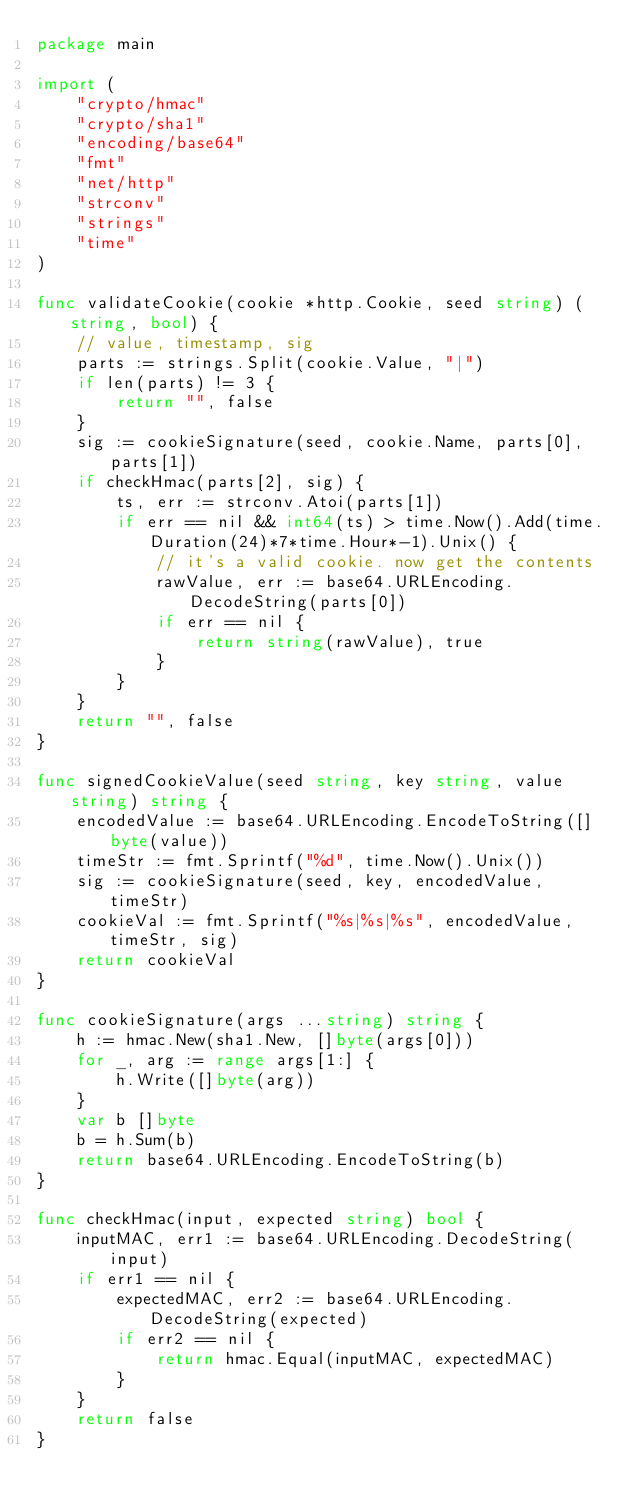<code> <loc_0><loc_0><loc_500><loc_500><_Go_>package main

import (
	"crypto/hmac"
	"crypto/sha1"
	"encoding/base64"
	"fmt"
	"net/http"
	"strconv"
	"strings"
	"time"
)

func validateCookie(cookie *http.Cookie, seed string) (string, bool) {
	// value, timestamp, sig
	parts := strings.Split(cookie.Value, "|")
	if len(parts) != 3 {
		return "", false
	}
	sig := cookieSignature(seed, cookie.Name, parts[0], parts[1])
	if checkHmac(parts[2], sig) {
		ts, err := strconv.Atoi(parts[1])
		if err == nil && int64(ts) > time.Now().Add(time.Duration(24)*7*time.Hour*-1).Unix() {
			// it's a valid cookie. now get the contents
			rawValue, err := base64.URLEncoding.DecodeString(parts[0])
			if err == nil {
				return string(rawValue), true
			}
		}
	}
	return "", false
}

func signedCookieValue(seed string, key string, value string) string {
	encodedValue := base64.URLEncoding.EncodeToString([]byte(value))
	timeStr := fmt.Sprintf("%d", time.Now().Unix())
	sig := cookieSignature(seed, key, encodedValue, timeStr)
	cookieVal := fmt.Sprintf("%s|%s|%s", encodedValue, timeStr, sig)
	return cookieVal
}

func cookieSignature(args ...string) string {
	h := hmac.New(sha1.New, []byte(args[0]))
	for _, arg := range args[1:] {
		h.Write([]byte(arg))
	}
	var b []byte
	b = h.Sum(b)
	return base64.URLEncoding.EncodeToString(b)
}

func checkHmac(input, expected string) bool {
	inputMAC, err1 := base64.URLEncoding.DecodeString(input)
	if err1 == nil {
		expectedMAC, err2 := base64.URLEncoding.DecodeString(expected)
		if err2 == nil {
			return hmac.Equal(inputMAC, expectedMAC)
		}
	}
	return false
}
</code> 